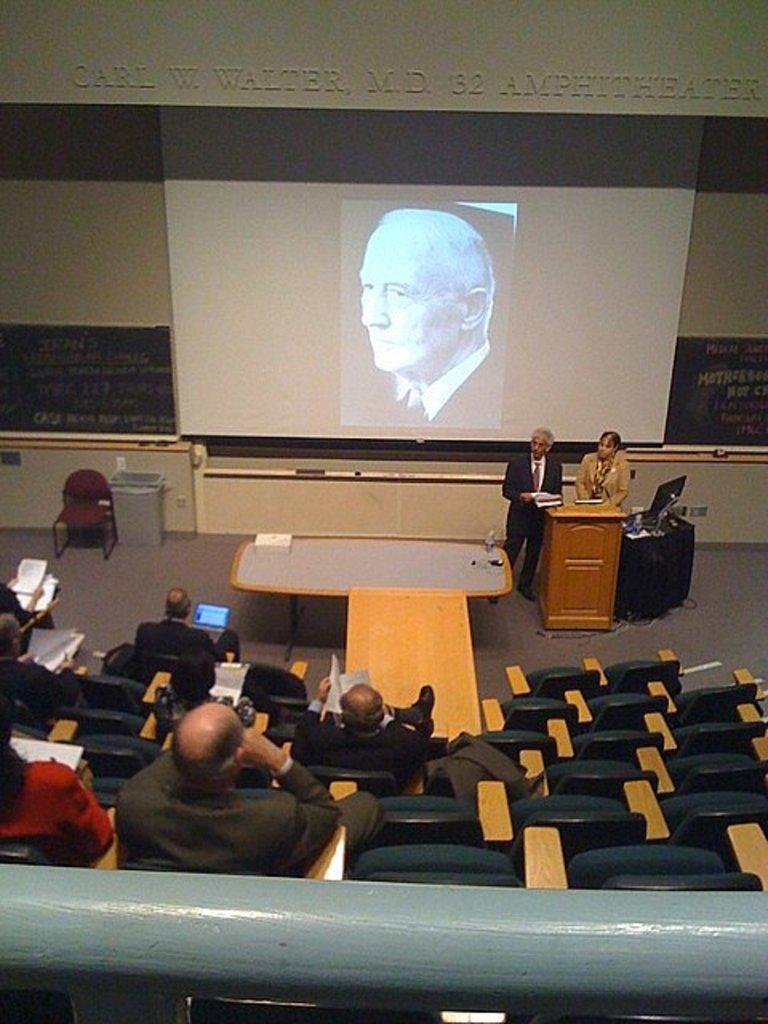Can you describe this image briefly? Here we can see a two people are standing on the floor,and here a group of people are sitting on the chair, and here is the projector. 